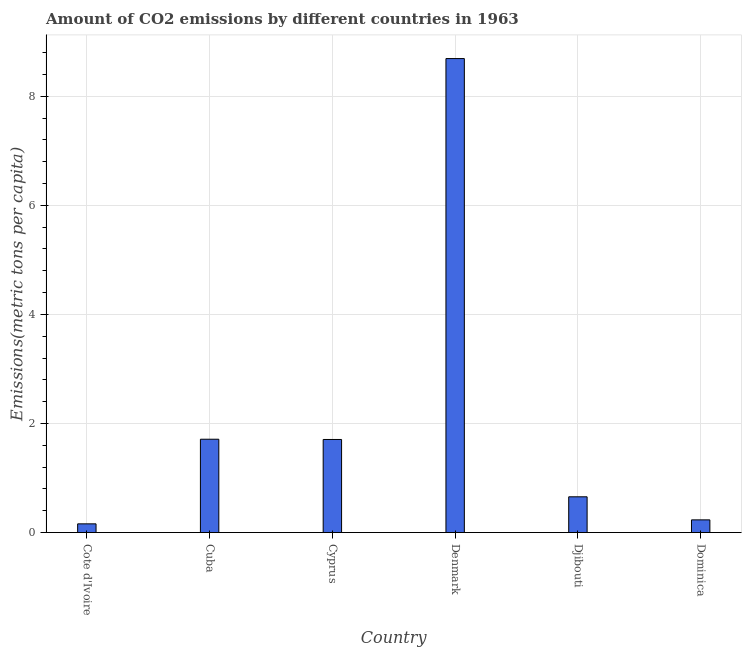Does the graph contain grids?
Provide a short and direct response. Yes. What is the title of the graph?
Offer a very short reply. Amount of CO2 emissions by different countries in 1963. What is the label or title of the Y-axis?
Your answer should be very brief. Emissions(metric tons per capita). What is the amount of co2 emissions in Cuba?
Provide a succinct answer. 1.71. Across all countries, what is the maximum amount of co2 emissions?
Your answer should be very brief. 8.69. Across all countries, what is the minimum amount of co2 emissions?
Provide a succinct answer. 0.16. In which country was the amount of co2 emissions maximum?
Offer a terse response. Denmark. In which country was the amount of co2 emissions minimum?
Offer a terse response. Cote d'Ivoire. What is the sum of the amount of co2 emissions?
Make the answer very short. 13.16. What is the difference between the amount of co2 emissions in Cuba and Djibouti?
Your answer should be compact. 1.06. What is the average amount of co2 emissions per country?
Ensure brevity in your answer.  2.19. What is the median amount of co2 emissions?
Provide a short and direct response. 1.18. What is the ratio of the amount of co2 emissions in Djibouti to that in Dominica?
Give a very brief answer. 2.81. Is the amount of co2 emissions in Denmark less than that in Djibouti?
Offer a very short reply. No. What is the difference between the highest and the second highest amount of co2 emissions?
Offer a very short reply. 6.98. What is the difference between the highest and the lowest amount of co2 emissions?
Your answer should be compact. 8.53. In how many countries, is the amount of co2 emissions greater than the average amount of co2 emissions taken over all countries?
Your answer should be very brief. 1. How many bars are there?
Make the answer very short. 6. Are the values on the major ticks of Y-axis written in scientific E-notation?
Make the answer very short. No. What is the Emissions(metric tons per capita) in Cote d'Ivoire?
Make the answer very short. 0.16. What is the Emissions(metric tons per capita) of Cuba?
Keep it short and to the point. 1.71. What is the Emissions(metric tons per capita) in Cyprus?
Offer a terse response. 1.71. What is the Emissions(metric tons per capita) of Denmark?
Make the answer very short. 8.69. What is the Emissions(metric tons per capita) of Djibouti?
Offer a very short reply. 0.66. What is the Emissions(metric tons per capita) in Dominica?
Ensure brevity in your answer.  0.23. What is the difference between the Emissions(metric tons per capita) in Cote d'Ivoire and Cuba?
Provide a succinct answer. -1.55. What is the difference between the Emissions(metric tons per capita) in Cote d'Ivoire and Cyprus?
Offer a terse response. -1.55. What is the difference between the Emissions(metric tons per capita) in Cote d'Ivoire and Denmark?
Keep it short and to the point. -8.53. What is the difference between the Emissions(metric tons per capita) in Cote d'Ivoire and Djibouti?
Provide a succinct answer. -0.5. What is the difference between the Emissions(metric tons per capita) in Cote d'Ivoire and Dominica?
Give a very brief answer. -0.07. What is the difference between the Emissions(metric tons per capita) in Cuba and Cyprus?
Offer a terse response. 0. What is the difference between the Emissions(metric tons per capita) in Cuba and Denmark?
Keep it short and to the point. -6.98. What is the difference between the Emissions(metric tons per capita) in Cuba and Djibouti?
Your response must be concise. 1.06. What is the difference between the Emissions(metric tons per capita) in Cuba and Dominica?
Provide a short and direct response. 1.48. What is the difference between the Emissions(metric tons per capita) in Cyprus and Denmark?
Offer a very short reply. -6.98. What is the difference between the Emissions(metric tons per capita) in Cyprus and Djibouti?
Your response must be concise. 1.05. What is the difference between the Emissions(metric tons per capita) in Cyprus and Dominica?
Your answer should be very brief. 1.47. What is the difference between the Emissions(metric tons per capita) in Denmark and Djibouti?
Your answer should be compact. 8.03. What is the difference between the Emissions(metric tons per capita) in Denmark and Dominica?
Provide a short and direct response. 8.46. What is the difference between the Emissions(metric tons per capita) in Djibouti and Dominica?
Your answer should be compact. 0.42. What is the ratio of the Emissions(metric tons per capita) in Cote d'Ivoire to that in Cuba?
Provide a short and direct response. 0.09. What is the ratio of the Emissions(metric tons per capita) in Cote d'Ivoire to that in Cyprus?
Your response must be concise. 0.09. What is the ratio of the Emissions(metric tons per capita) in Cote d'Ivoire to that in Denmark?
Provide a succinct answer. 0.02. What is the ratio of the Emissions(metric tons per capita) in Cote d'Ivoire to that in Djibouti?
Make the answer very short. 0.24. What is the ratio of the Emissions(metric tons per capita) in Cote d'Ivoire to that in Dominica?
Your answer should be very brief. 0.69. What is the ratio of the Emissions(metric tons per capita) in Cuba to that in Denmark?
Offer a very short reply. 0.2. What is the ratio of the Emissions(metric tons per capita) in Cuba to that in Djibouti?
Your answer should be compact. 2.61. What is the ratio of the Emissions(metric tons per capita) in Cuba to that in Dominica?
Offer a very short reply. 7.34. What is the ratio of the Emissions(metric tons per capita) in Cyprus to that in Denmark?
Keep it short and to the point. 0.2. What is the ratio of the Emissions(metric tons per capita) in Cyprus to that in Djibouti?
Your answer should be compact. 2.6. What is the ratio of the Emissions(metric tons per capita) in Cyprus to that in Dominica?
Give a very brief answer. 7.32. What is the ratio of the Emissions(metric tons per capita) in Denmark to that in Djibouti?
Provide a succinct answer. 13.25. What is the ratio of the Emissions(metric tons per capita) in Denmark to that in Dominica?
Your response must be concise. 37.28. What is the ratio of the Emissions(metric tons per capita) in Djibouti to that in Dominica?
Ensure brevity in your answer.  2.81. 